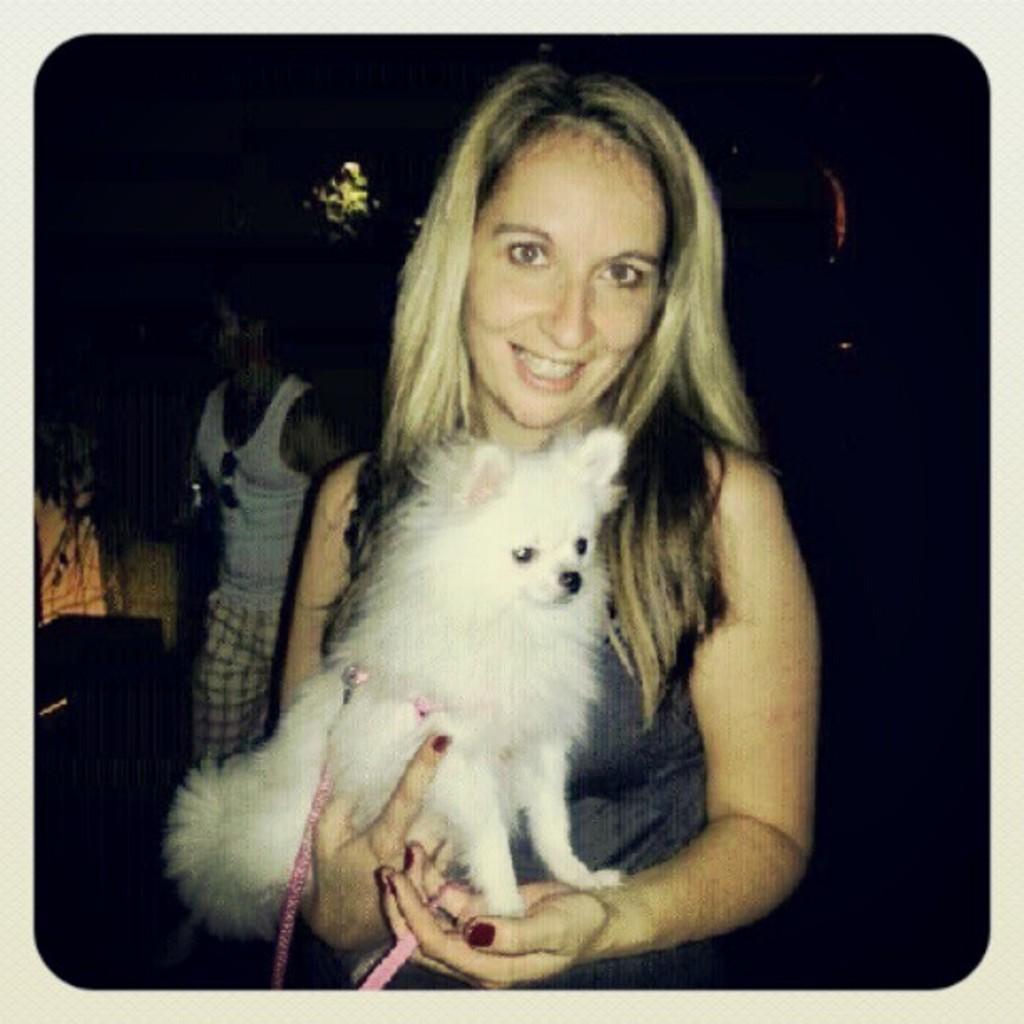Can you describe this image briefly? In this image in the center there is one woman who is smiling, and she is holding a puppy beside her there is another person. 